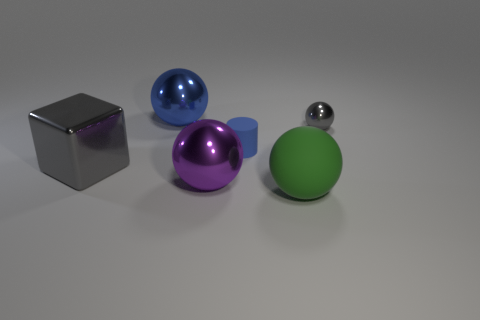How many large spheres are in front of the small blue rubber thing and behind the big green matte sphere?
Your answer should be very brief. 1. What material is the large gray object?
Your response must be concise. Metal. Are there any other things that are the same color as the large cube?
Your answer should be very brief. Yes. Do the big blue ball and the large green thing have the same material?
Your answer should be compact. No. There is a large object that is in front of the metal ball that is in front of the large gray metal thing; how many big gray metal things are right of it?
Give a very brief answer. 0. How many big green matte spheres are there?
Offer a terse response. 1. Is the number of gray metal cubes that are on the right side of the large purple object less than the number of purple metallic things behind the large gray shiny object?
Your answer should be compact. No. Are there fewer large objects that are behind the tiny blue rubber thing than gray matte cubes?
Offer a terse response. No. What is the material of the big sphere behind the gray thing that is to the left of the big sphere in front of the purple metallic thing?
Offer a very short reply. Metal. How many objects are either big things that are behind the gray ball or shiny spheres that are behind the tiny ball?
Provide a succinct answer. 1. 